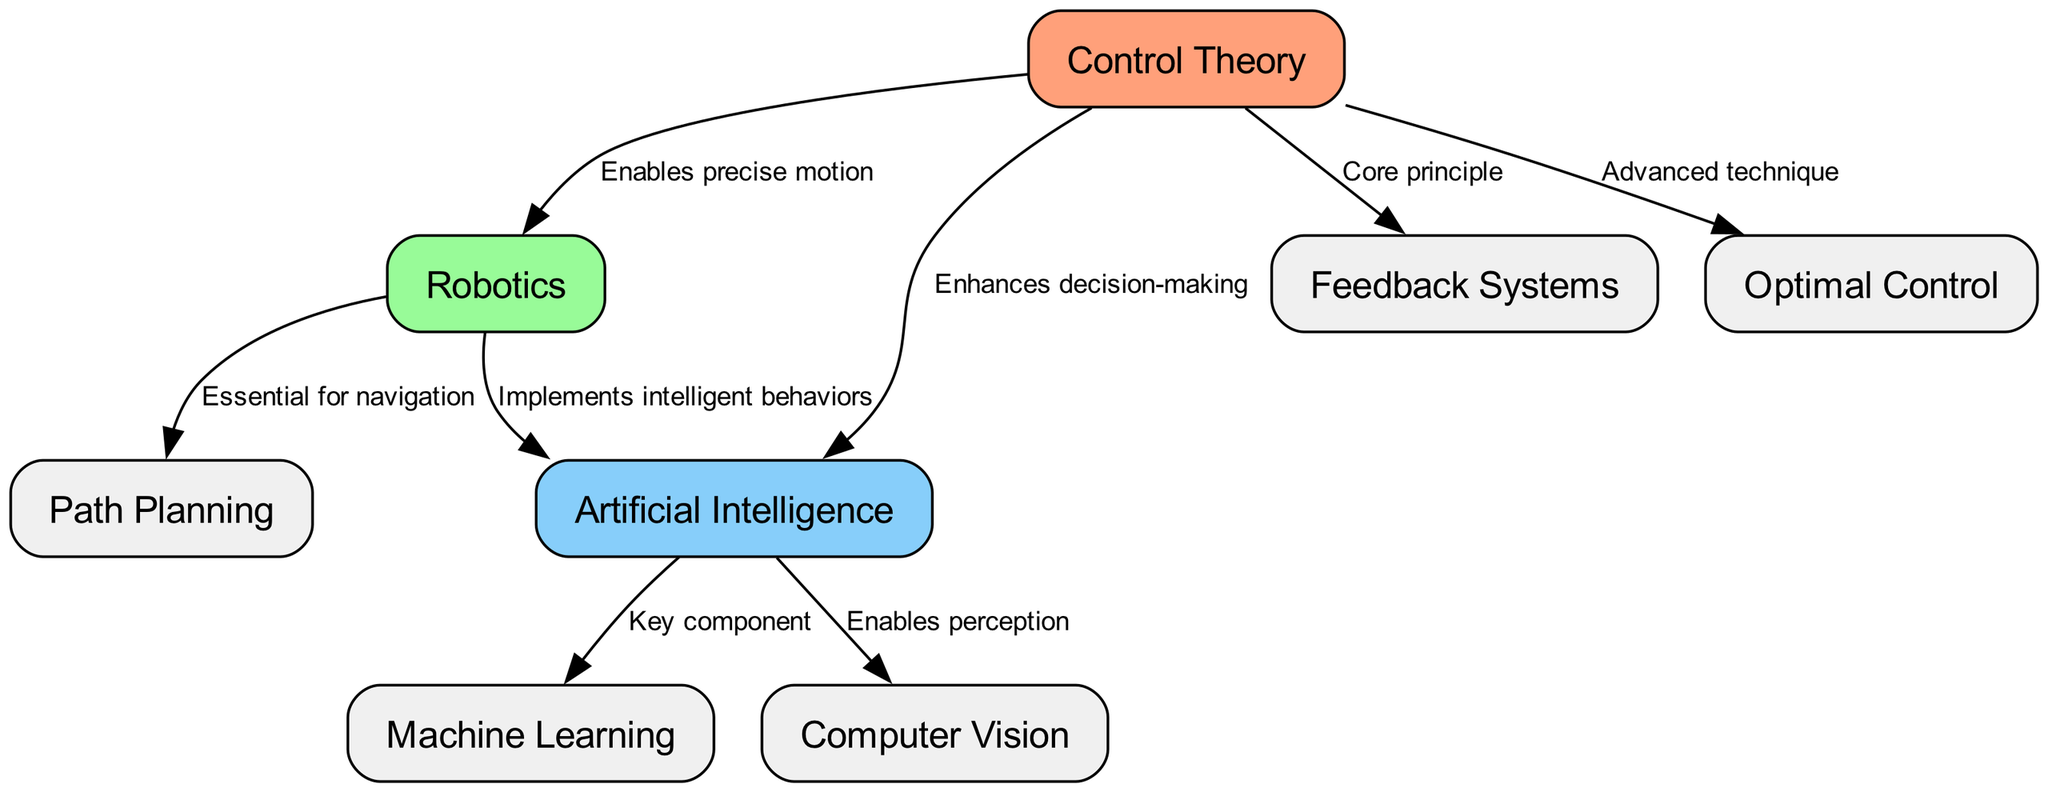What is the total number of nodes in the diagram? The diagram contains nodes listed under the "nodes" section in the data. Counting these gives us a total of 8 distinct nodes.
Answer: 8 What does Control Theory enhance in Artificial Intelligence? The edge connecting "Control Theory" to "Artificial Intelligence" specifies that it "Enhances decision-making," which directly answers the question.
Answer: decision-making Which node is described as essential for navigation in Robotics? Looking at the edge from "Robotics," it indicates that "Path Planning" is essential for navigation, providing the direct relationship needed to answer the question.
Answer: Path Planning How many edges connect to Control Theory? By examining the edges listed in the data, we count 4 connections coming into or out of the "Control Theory" node, specifically through different labeled edges, fulfilling the request for the number of edges.
Answer: 4 What is a key component of Artificial Intelligence? The edge from "Artificial Intelligence" to "Machine Learning" states that it is a "Key component." Thus, selecting this edge directly provides the answer required by the question.
Answer: Machine Learning Which two fields does Control Theory enable precise motion for? The edge from "Control Theory" to "Robotics" clearly states it enables precise motion, and the reasoning through the links shows that Robotics is the only field specified. So the answer is directly related to Robotics as the field influenced by Control Theory.
Answer: Robotics What is the core principle of Feedback Systems? The data indicates a direct edge from "Control Theory" to "Feedback Systems" that labels it as the "Core principle." This connection is clear enough to answer the question confidently.
Answer: Core principle Which branch connects Artificial Intelligence to Computer Vision? There is an edge from "Artificial Intelligence" to "Computer Vision" that indicates it "Enables perception." This relationship clarifies the connection asked for in the question.
Answer: Computer Vision 